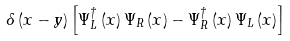Convert formula to latex. <formula><loc_0><loc_0><loc_500><loc_500>\delta \left ( x - y \right ) \left [ \Psi _ { L } ^ { \dagger } \left ( x \right ) \Psi _ { R } \left ( x \right ) - \Psi _ { R } ^ { \dagger } \left ( x \right ) \Psi _ { L } \left ( x \right ) \right ]</formula> 